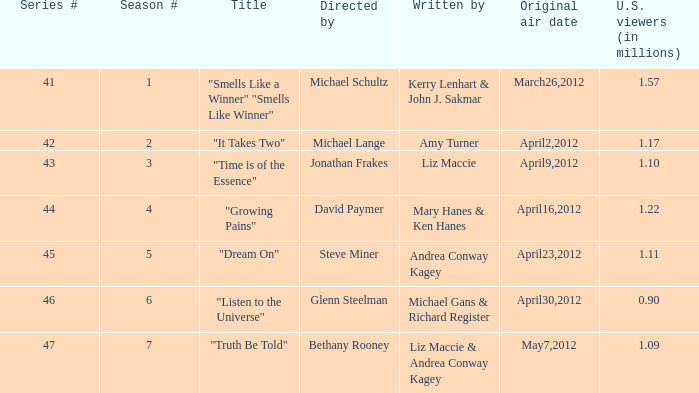When was the initial transmission of the episode called "truth be told"? May7,2012. 